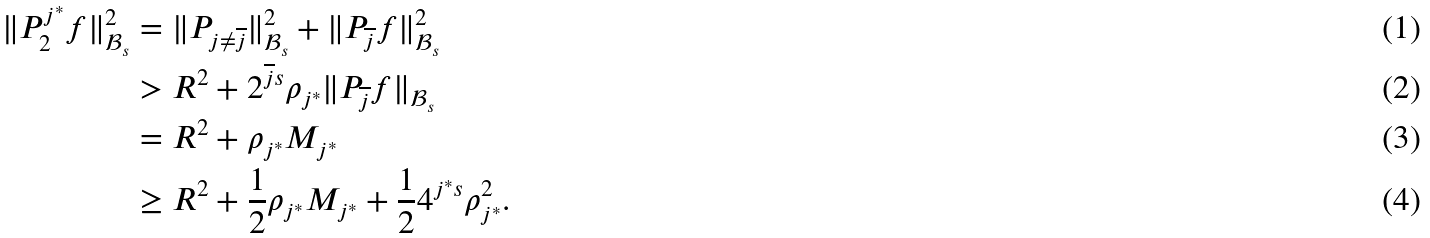Convert formula to latex. <formula><loc_0><loc_0><loc_500><loc_500>\| P _ { 2 } ^ { j ^ { \ast } } f \| _ { \mathcal { B } _ { s } } ^ { 2 } & = \| P _ { j \neq \overline { j } } \| _ { \mathcal { B } _ { s } } ^ { 2 } + \| P _ { \overline { j } } f \| _ { \mathcal { B } _ { s } } ^ { 2 } \\ & > R ^ { 2 } + 2 ^ { \overline { j } s } \rho _ { j ^ { \ast } } \| P _ { \overline { j } } f \| _ { \mathcal { B } _ { s } } \\ & = R ^ { 2 } + \rho _ { j ^ { \ast } } M _ { j ^ { \ast } } \\ & \geq R ^ { 2 } + \frac { 1 } { 2 } \rho _ { j ^ { \ast } } M _ { j ^ { \ast } } + \frac { 1 } { 2 } 4 ^ { j ^ { \ast } s } \rho _ { j ^ { \ast } } ^ { 2 } .</formula> 